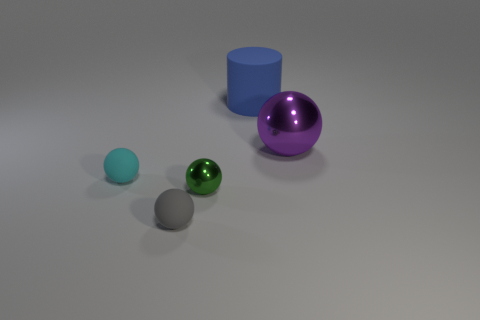Subtract all balls. How many objects are left? 1 Add 1 small yellow rubber blocks. How many objects exist? 6 Subtract all purple spheres. How many spheres are left? 3 Subtract all large purple balls. How many balls are left? 3 Subtract 1 green balls. How many objects are left? 4 Subtract 1 cylinders. How many cylinders are left? 0 Subtract all red spheres. Subtract all blue cylinders. How many spheres are left? 4 Subtract all blue balls. How many gray cylinders are left? 0 Subtract all blue metal cylinders. Subtract all small cyan rubber objects. How many objects are left? 4 Add 4 matte things. How many matte things are left? 7 